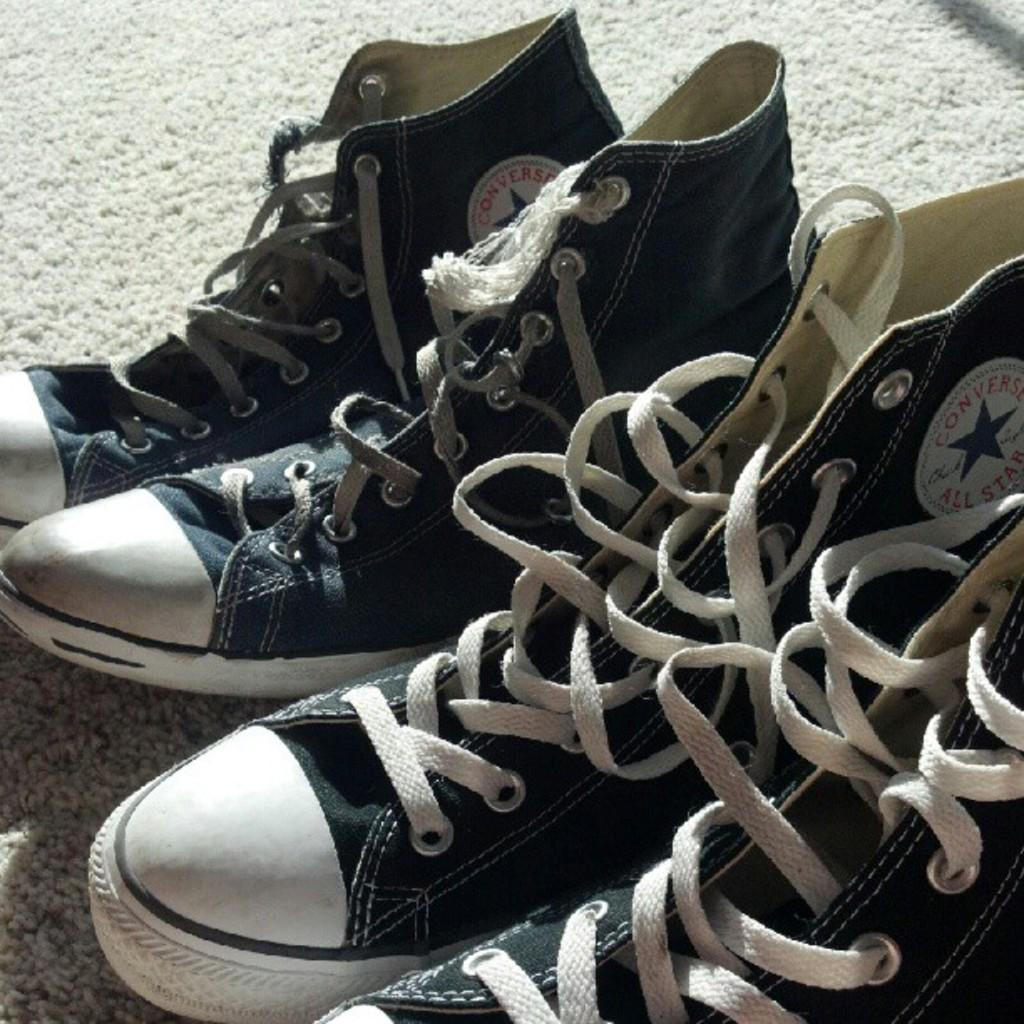How many pairs of shoes are visible in the image? There are two pairs of shoes in the image. Where are the shoes located? The shoes are on a mat. What type of glass is used to make the horn in the image? There is no horn or glass present in the image; it only features two pairs of shoes on a mat. 